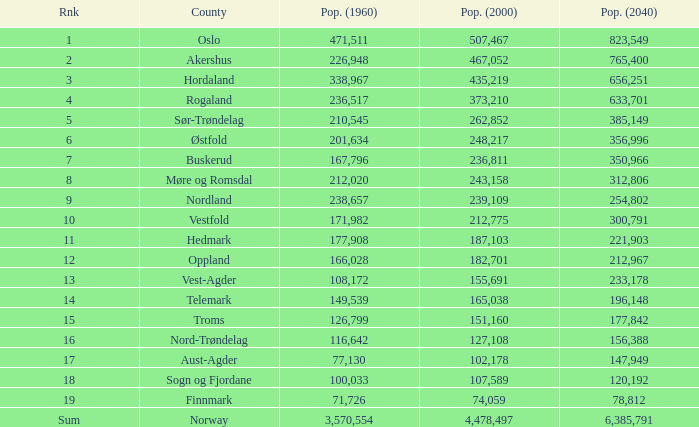What was the population of a county in 2040 that had a population less than 108,172 in 2000 and less than 107,589 in 1960? 2.0. 